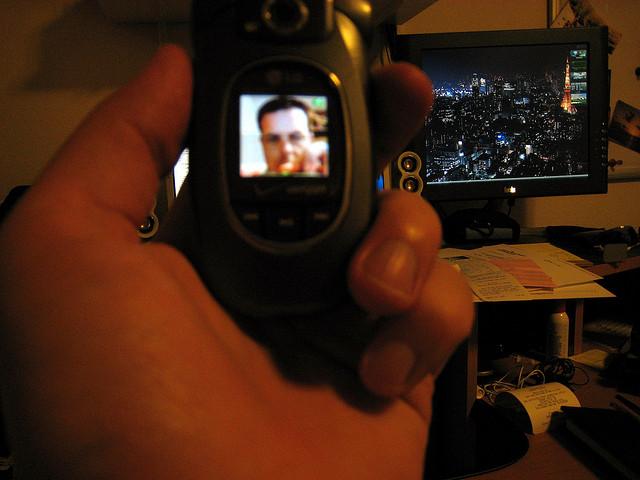Is this person sitting near food?
Short answer required. No. What make is this phone?
Be succinct. Motorola. Is this person paying attention to the television screen?
Write a very short answer. No. Did the man taking a selfie?
Give a very brief answer. Yes. What does the hand light represent?
Keep it brief. Phone. What gender is on the phone?
Be succinct. Male. 